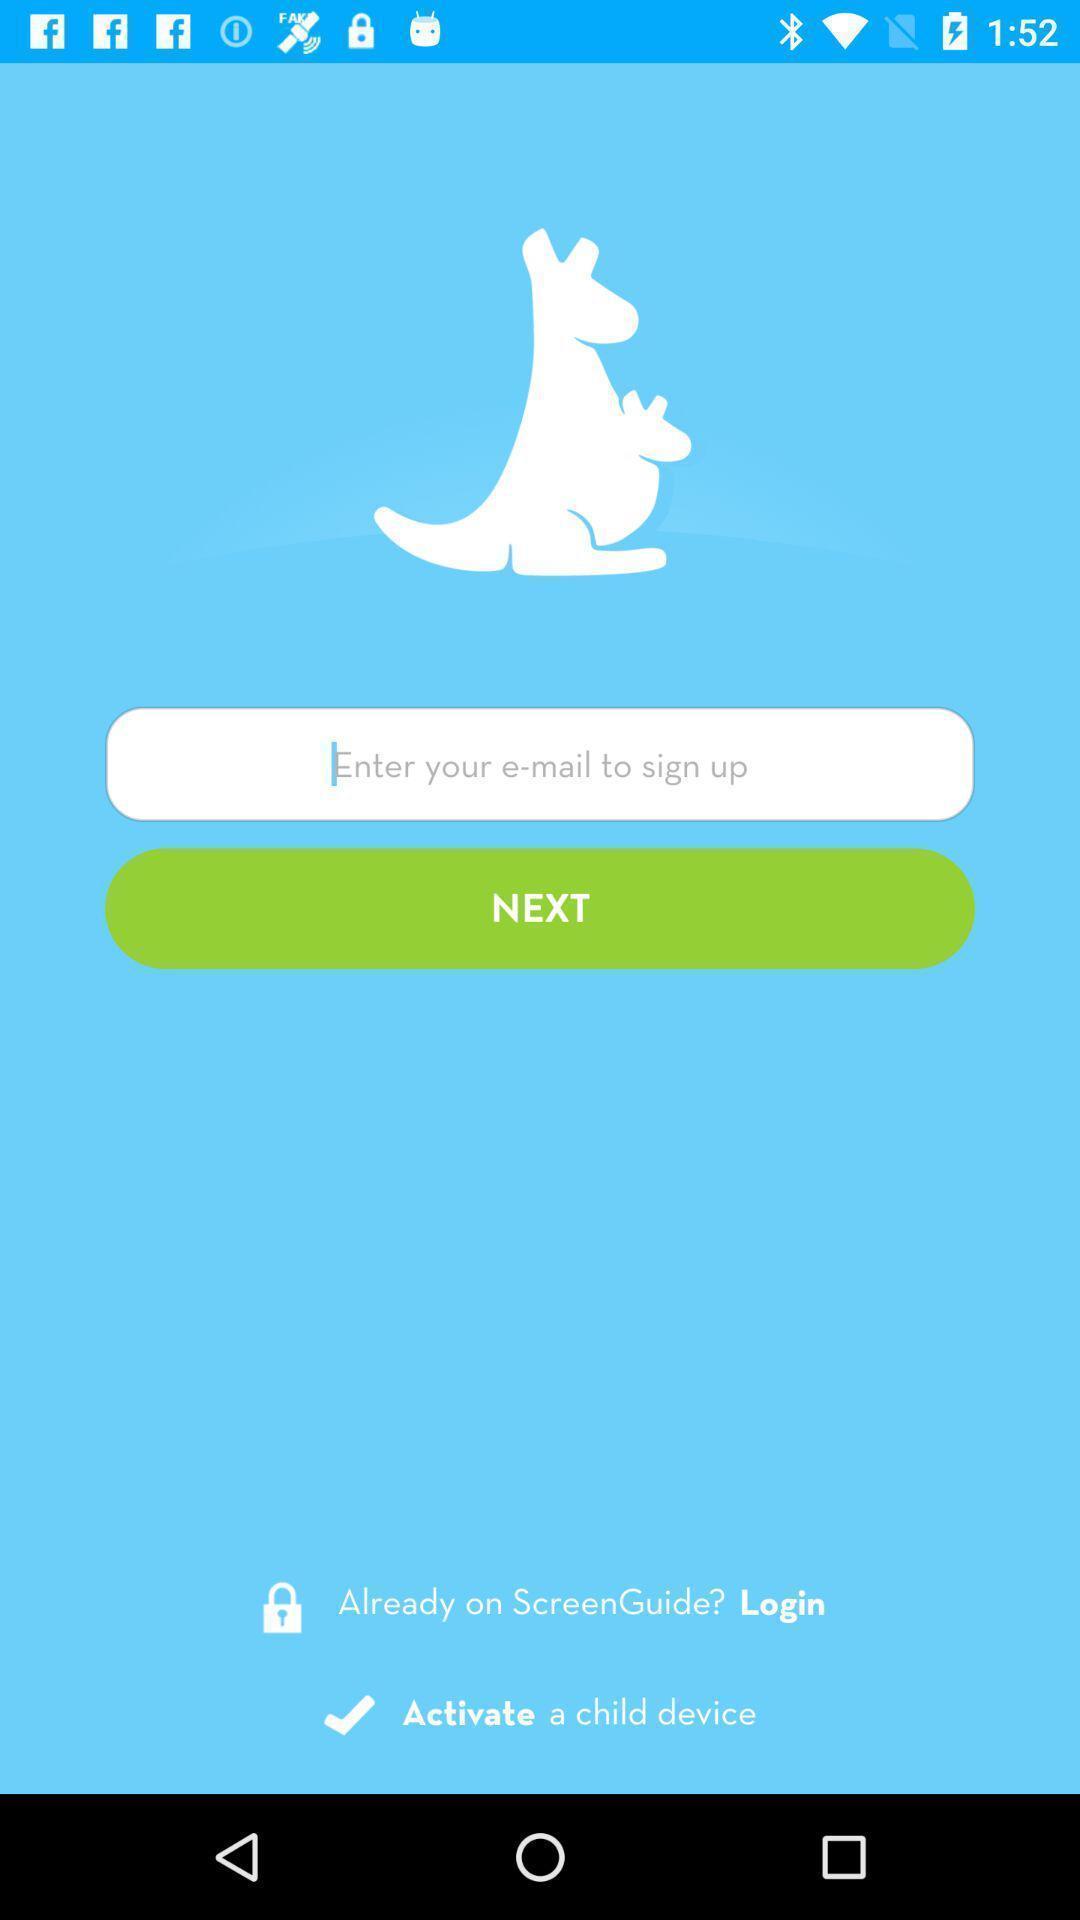Describe the visual elements of this screenshot. Sign-up page of a security app. 